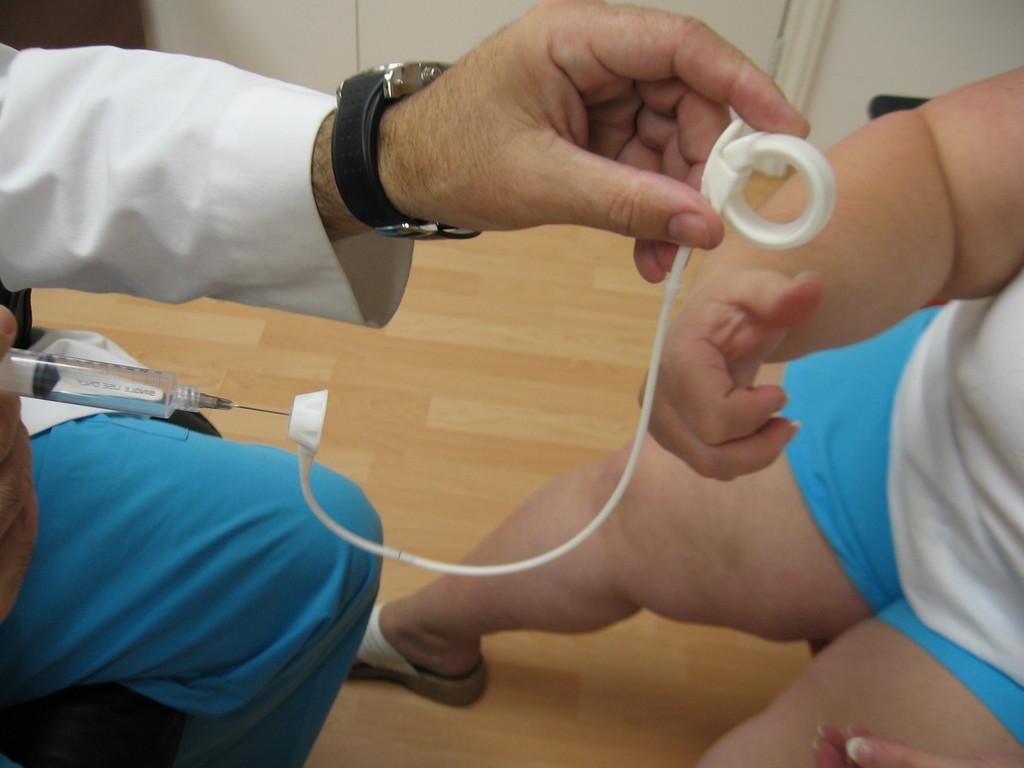Can you describe this image briefly? In the picture we can see a doctor sitting and holding an injection and in it we can see a white colored wire and he is holding it with the other hand and in front of him we can see a small baby and to the floor we can see wooden mat and the wall is white in color. 